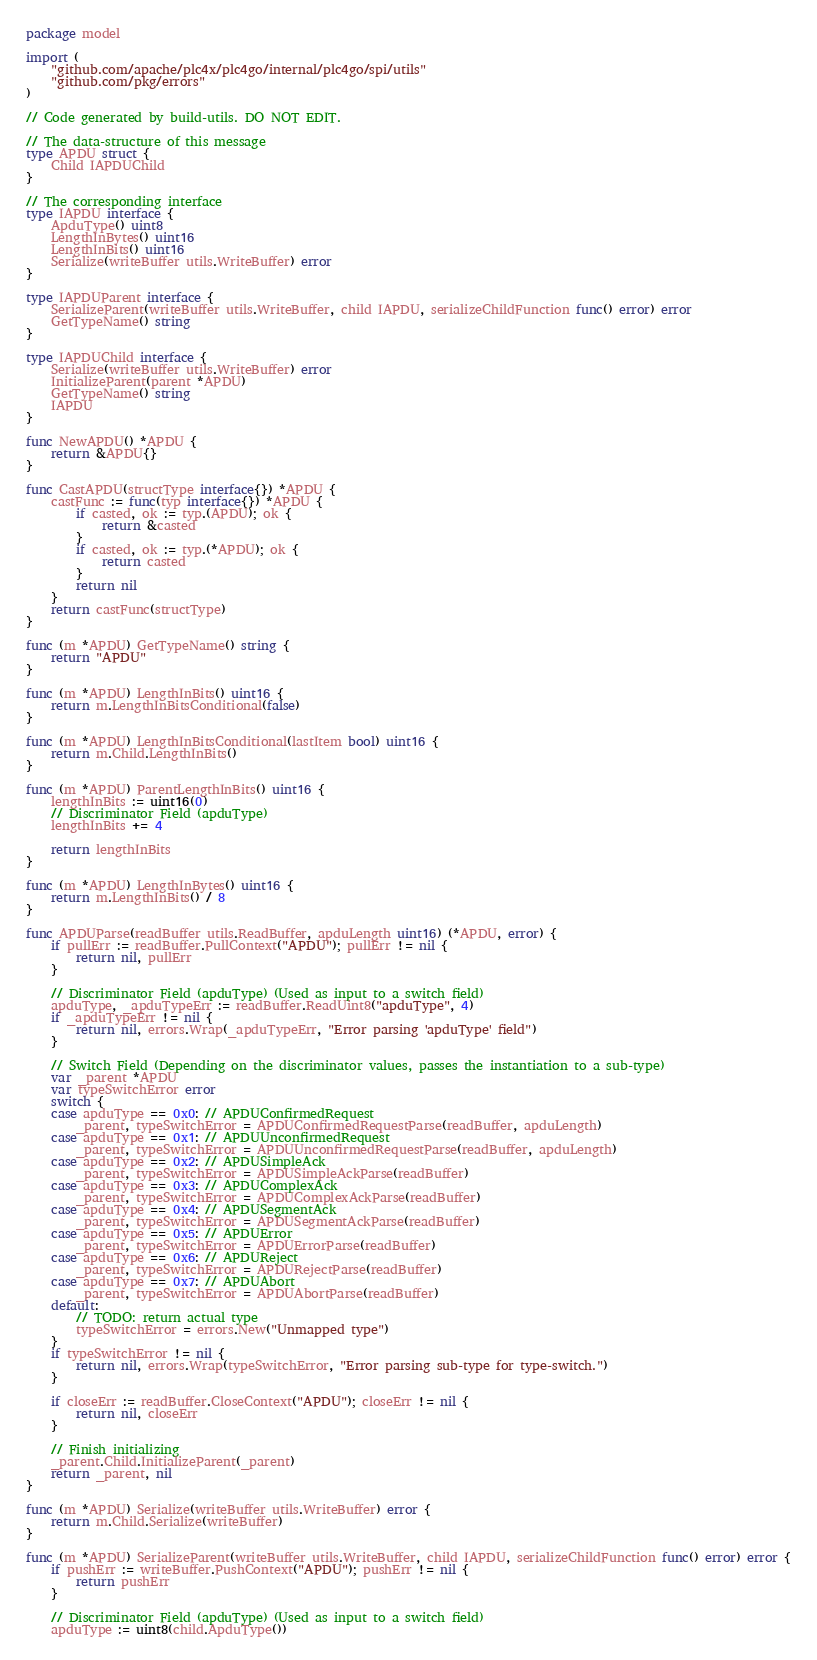Convert code to text. <code><loc_0><loc_0><loc_500><loc_500><_Go_>package model

import (
	"github.com/apache/plc4x/plc4go/internal/plc4go/spi/utils"
	"github.com/pkg/errors"
)

// Code generated by build-utils. DO NOT EDIT.

// The data-structure of this message
type APDU struct {
	Child IAPDUChild
}

// The corresponding interface
type IAPDU interface {
	ApduType() uint8
	LengthInBytes() uint16
	LengthInBits() uint16
	Serialize(writeBuffer utils.WriteBuffer) error
}

type IAPDUParent interface {
	SerializeParent(writeBuffer utils.WriteBuffer, child IAPDU, serializeChildFunction func() error) error
	GetTypeName() string
}

type IAPDUChild interface {
	Serialize(writeBuffer utils.WriteBuffer) error
	InitializeParent(parent *APDU)
	GetTypeName() string
	IAPDU
}

func NewAPDU() *APDU {
	return &APDU{}
}

func CastAPDU(structType interface{}) *APDU {
	castFunc := func(typ interface{}) *APDU {
		if casted, ok := typ.(APDU); ok {
			return &casted
		}
		if casted, ok := typ.(*APDU); ok {
			return casted
		}
		return nil
	}
	return castFunc(structType)
}

func (m *APDU) GetTypeName() string {
	return "APDU"
}

func (m *APDU) LengthInBits() uint16 {
	return m.LengthInBitsConditional(false)
}

func (m *APDU) LengthInBitsConditional(lastItem bool) uint16 {
	return m.Child.LengthInBits()
}

func (m *APDU) ParentLengthInBits() uint16 {
	lengthInBits := uint16(0)
	// Discriminator Field (apduType)
	lengthInBits += 4

	return lengthInBits
}

func (m *APDU) LengthInBytes() uint16 {
	return m.LengthInBits() / 8
}

func APDUParse(readBuffer utils.ReadBuffer, apduLength uint16) (*APDU, error) {
	if pullErr := readBuffer.PullContext("APDU"); pullErr != nil {
		return nil, pullErr
	}

	// Discriminator Field (apduType) (Used as input to a switch field)
	apduType, _apduTypeErr := readBuffer.ReadUint8("apduType", 4)
	if _apduTypeErr != nil {
		return nil, errors.Wrap(_apduTypeErr, "Error parsing 'apduType' field")
	}

	// Switch Field (Depending on the discriminator values, passes the instantiation to a sub-type)
	var _parent *APDU
	var typeSwitchError error
	switch {
	case apduType == 0x0: // APDUConfirmedRequest
		_parent, typeSwitchError = APDUConfirmedRequestParse(readBuffer, apduLength)
	case apduType == 0x1: // APDUUnconfirmedRequest
		_parent, typeSwitchError = APDUUnconfirmedRequestParse(readBuffer, apduLength)
	case apduType == 0x2: // APDUSimpleAck
		_parent, typeSwitchError = APDUSimpleAckParse(readBuffer)
	case apduType == 0x3: // APDUComplexAck
		_parent, typeSwitchError = APDUComplexAckParse(readBuffer)
	case apduType == 0x4: // APDUSegmentAck
		_parent, typeSwitchError = APDUSegmentAckParse(readBuffer)
	case apduType == 0x5: // APDUError
		_parent, typeSwitchError = APDUErrorParse(readBuffer)
	case apduType == 0x6: // APDUReject
		_parent, typeSwitchError = APDURejectParse(readBuffer)
	case apduType == 0x7: // APDUAbort
		_parent, typeSwitchError = APDUAbortParse(readBuffer)
	default:
		// TODO: return actual type
		typeSwitchError = errors.New("Unmapped type")
	}
	if typeSwitchError != nil {
		return nil, errors.Wrap(typeSwitchError, "Error parsing sub-type for type-switch.")
	}

	if closeErr := readBuffer.CloseContext("APDU"); closeErr != nil {
		return nil, closeErr
	}

	// Finish initializing
	_parent.Child.InitializeParent(_parent)
	return _parent, nil
}

func (m *APDU) Serialize(writeBuffer utils.WriteBuffer) error {
	return m.Child.Serialize(writeBuffer)
}

func (m *APDU) SerializeParent(writeBuffer utils.WriteBuffer, child IAPDU, serializeChildFunction func() error) error {
	if pushErr := writeBuffer.PushContext("APDU"); pushErr != nil {
		return pushErr
	}

	// Discriminator Field (apduType) (Used as input to a switch field)
	apduType := uint8(child.ApduType())</code> 